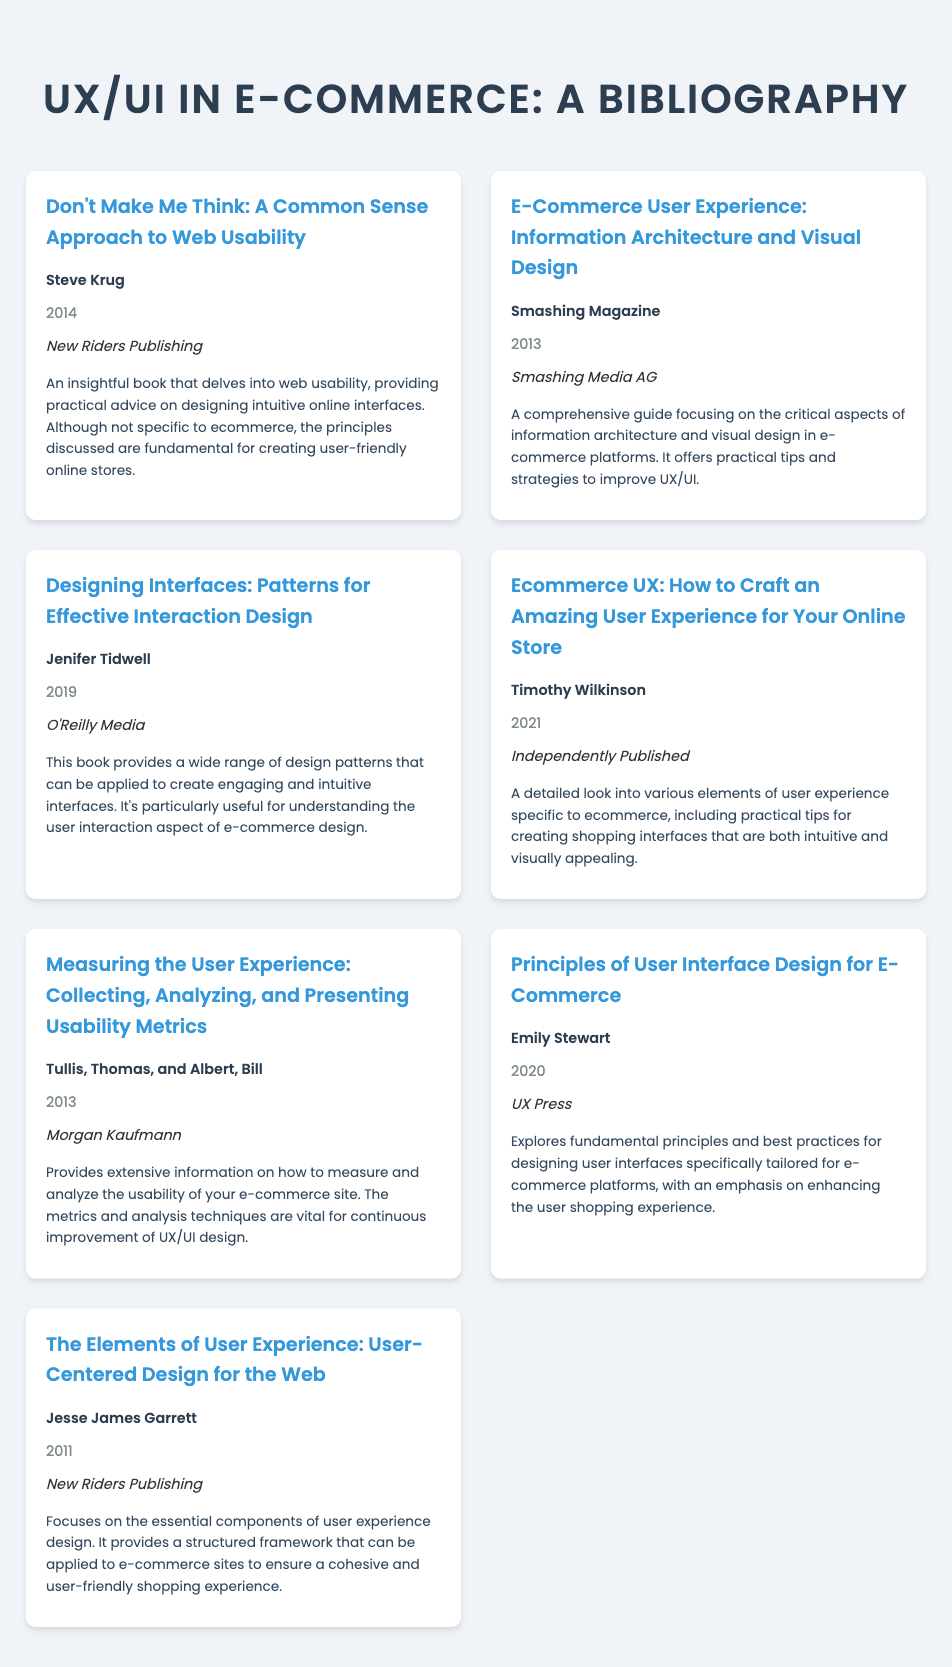what is the title of the first book listed? The title of the first book is mentioned at the top of the bibliography section and is "Don't Make Me Think: A Common Sense Approach to Web Usability".
Answer: Don't Make Me Think: A Common Sense Approach to Web Usability who is the author of "Ecommerce UX: How to Craft an Amazing User Experience for Your Online Store"? The author of the book is provided in the bibliography entry under the author's name section for that title.
Answer: Timothy Wilkinson what year was "Principles of User Interface Design for E-Commerce" published? The publication year is given with each book entry, specifically for Emily Stewart's book as 2020.
Answer: 2020 which publishing company published "Measuring the User Experience"? The publisher's name is indicated in the entry for the book, which is Morgan Kaufmann.
Answer: Morgan Kaufmann how many books in the bibliography are published after 2015? By examining the publication years in the document, the books published after 2015 are counted: “Ecommerce UX”, “Principles of User Interface Design for E-Commerce” and “Designing Interfaces”.
Answer: 3 which book discusses practical advice on designing intuitive online interfaces? The book that offers practical advice on interface design principles is specified and is titled "Don't Make Me Think".
Answer: Don't Make Me Think: A Common Sense Approach to Web Usability what is the primary focus of the "E-Commerce User Experience" book? The bibliography describes this book's focus on information architecture and visual design aspects in e-commerce platforms.
Answer: Information architecture and visual design who published the book "Designing Interfaces"? The publisher's name for this title is included in the respective entry, which is O'Reilly Media.
Answer: O'Reilly Media 